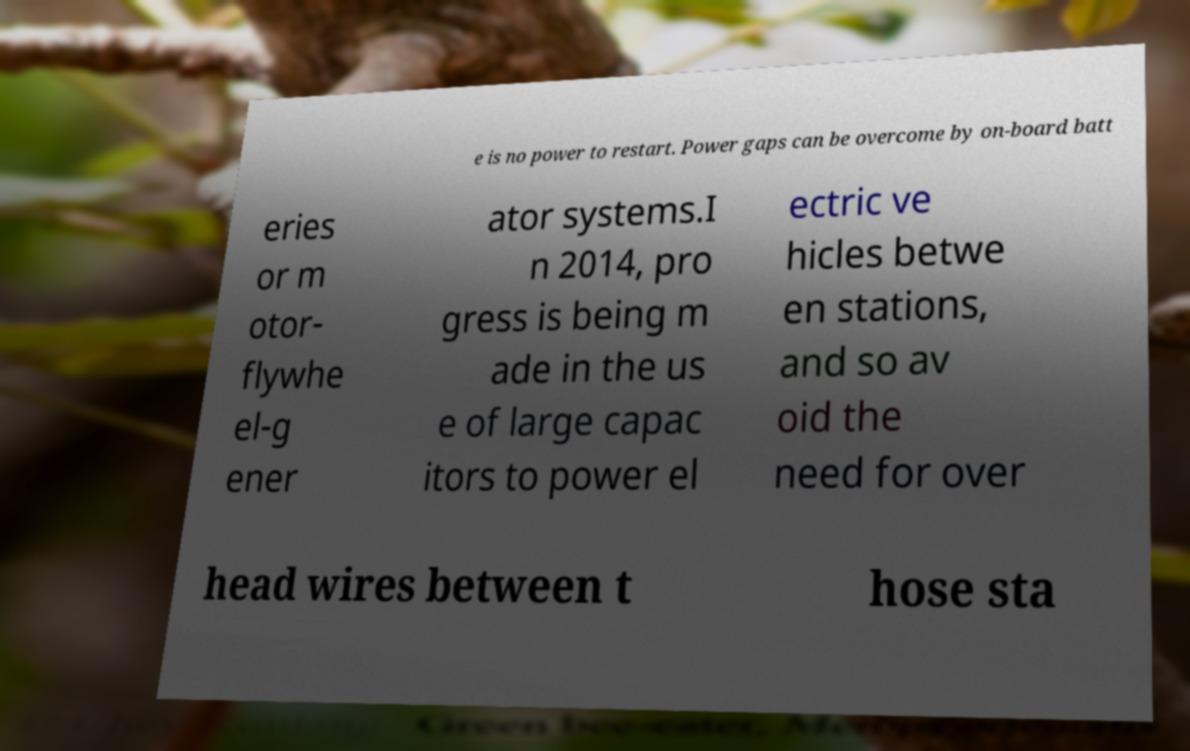Could you assist in decoding the text presented in this image and type it out clearly? e is no power to restart. Power gaps can be overcome by on-board batt eries or m otor- flywhe el-g ener ator systems.I n 2014, pro gress is being m ade in the us e of large capac itors to power el ectric ve hicles betwe en stations, and so av oid the need for over head wires between t hose sta 